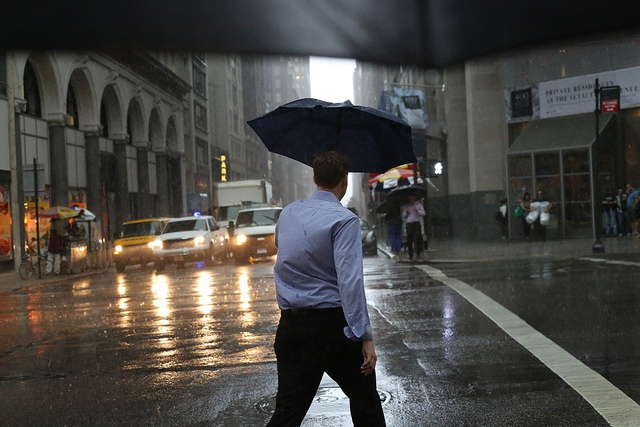Describe the objects in this image and their specific colors. I can see people in black, gray, and darkgray tones, umbrella in black, gray, and darkblue tones, car in black, maroon, darkgray, and gray tones, truck in black, maroon, gray, and lightgray tones, and truck in black, darkgray, and gray tones in this image. 